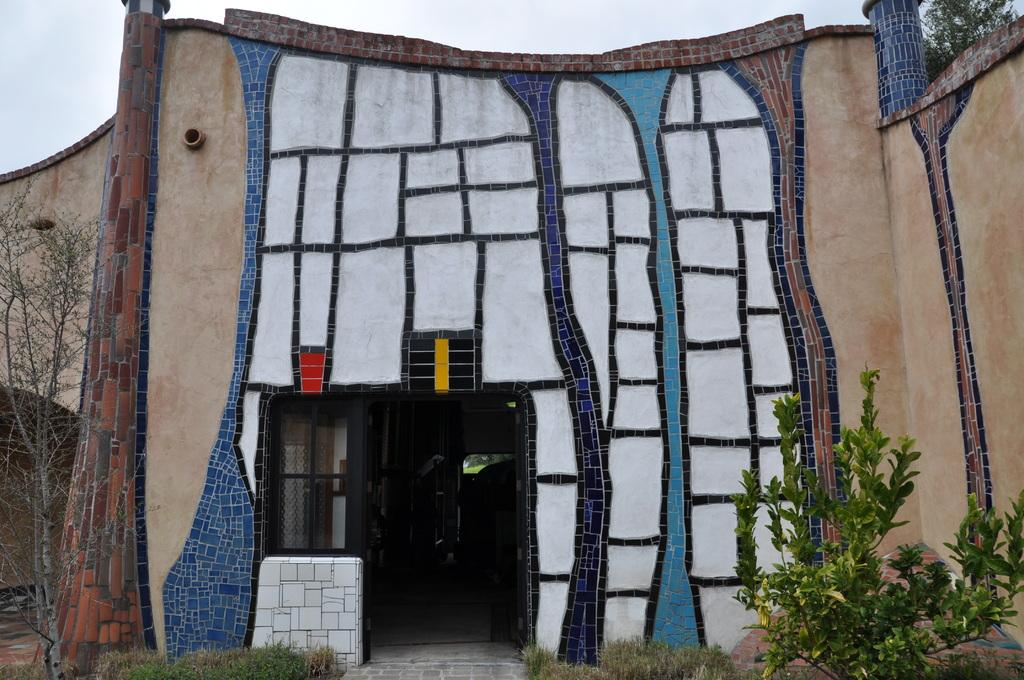What type of structure is present in the image? There is a building in the image. What can be seen in front of the building? There are trees in front of the building. Can you describe the window on the building? There is a black color window in the image. What is the color of the wall of the building? The wall of the building has a different color. What is the color of the sky in the image? The sky is blue and white in color. What type of battle is taking place in front of the building? There is no battle present in the image; it only shows a building with trees in front. Can you describe the earth's surface in the image? The image does not show the earth's surface; it only shows a building, trees, and the sky. 